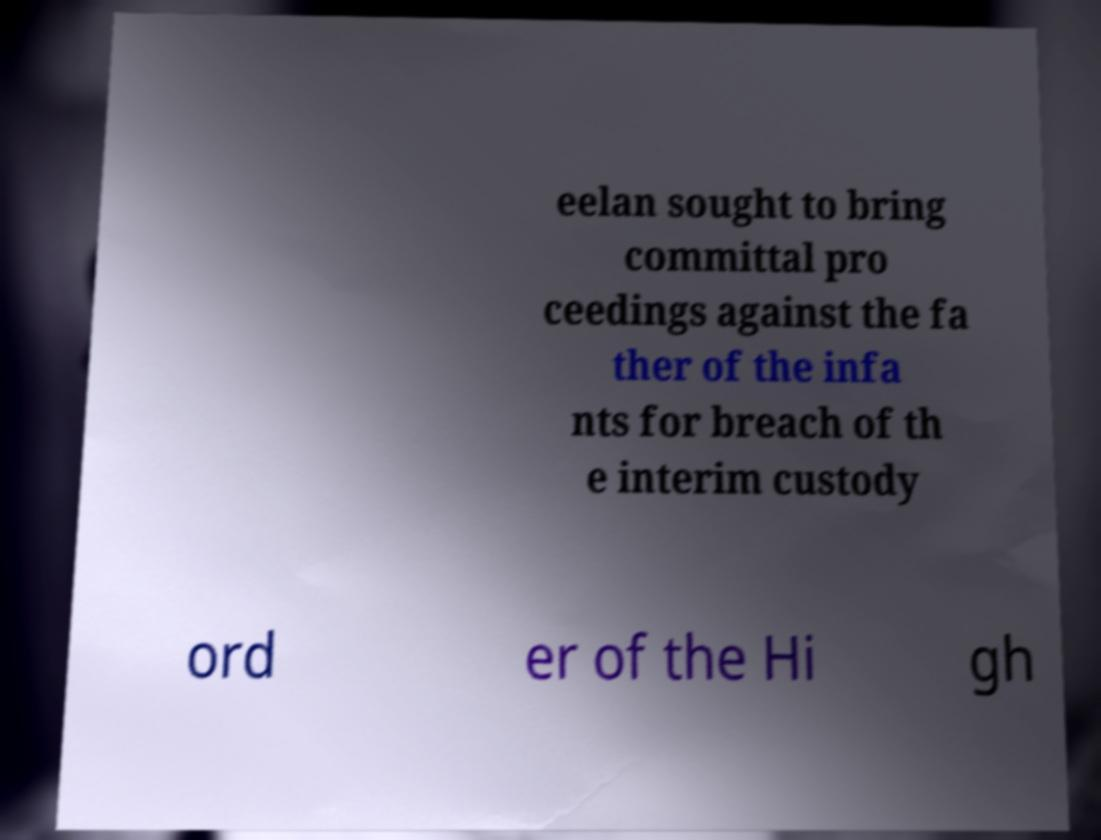Please identify and transcribe the text found in this image. eelan sought to bring committal pro ceedings against the fa ther of the infa nts for breach of th e interim custody ord er of the Hi gh 